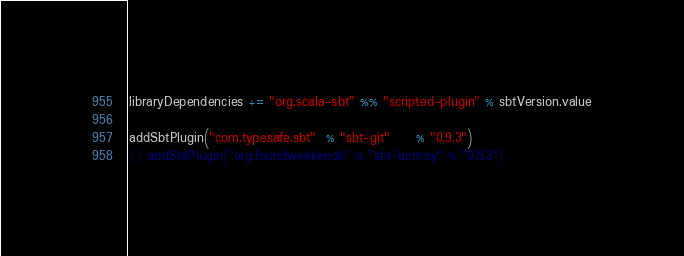<code> <loc_0><loc_0><loc_500><loc_500><_Scala_>libraryDependencies += "org.scala-sbt" %% "scripted-plugin" % sbtVersion.value

addSbtPlugin("com.typesafe.sbt"  % "sbt-git"     % "0.9.3")
// addSbtPlugin("org.foundweekends" % "sbt-bintray" % "0.5.3")
</code> 